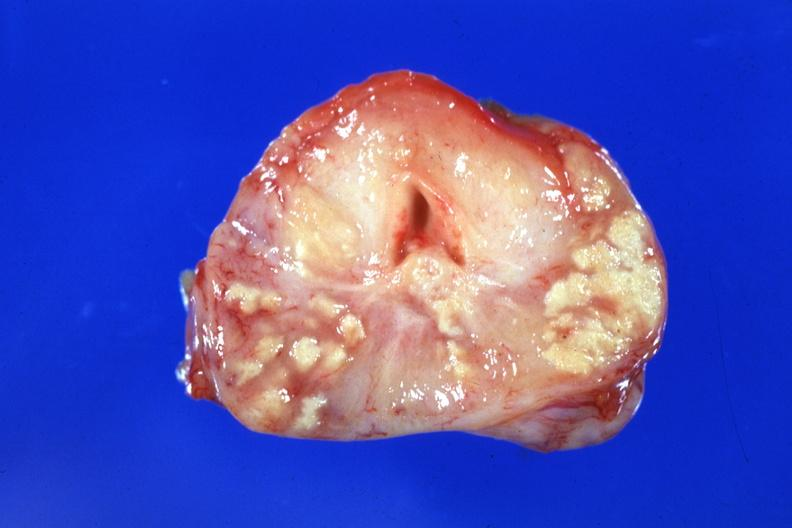what is present?
Answer the question using a single word or phrase. Prostate 